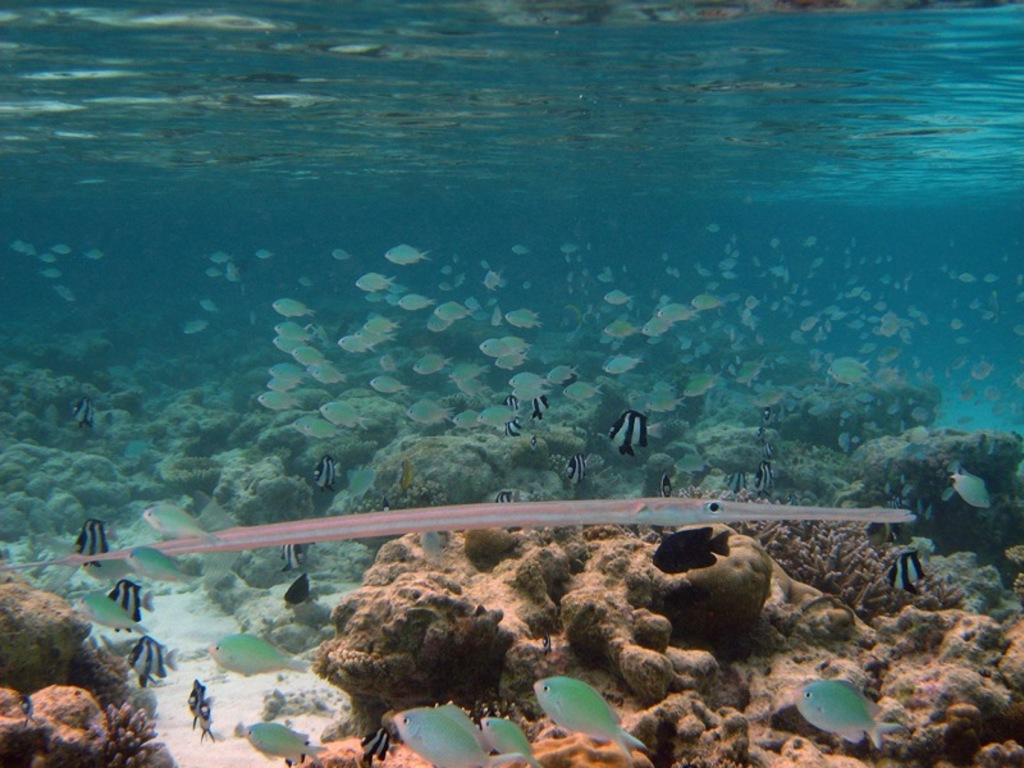What type of environment is shown in the image? The image depicts an underwater scene. What types of marine life can be seen in the image? There are different varieties of fishes in the image. What else can be found in the underwater environment in the image? There are corals in the image. What type of linen can be seen hanging from the church in the image? There is no church or linen present in the image; it is an underwater scene with fishes and corals. 